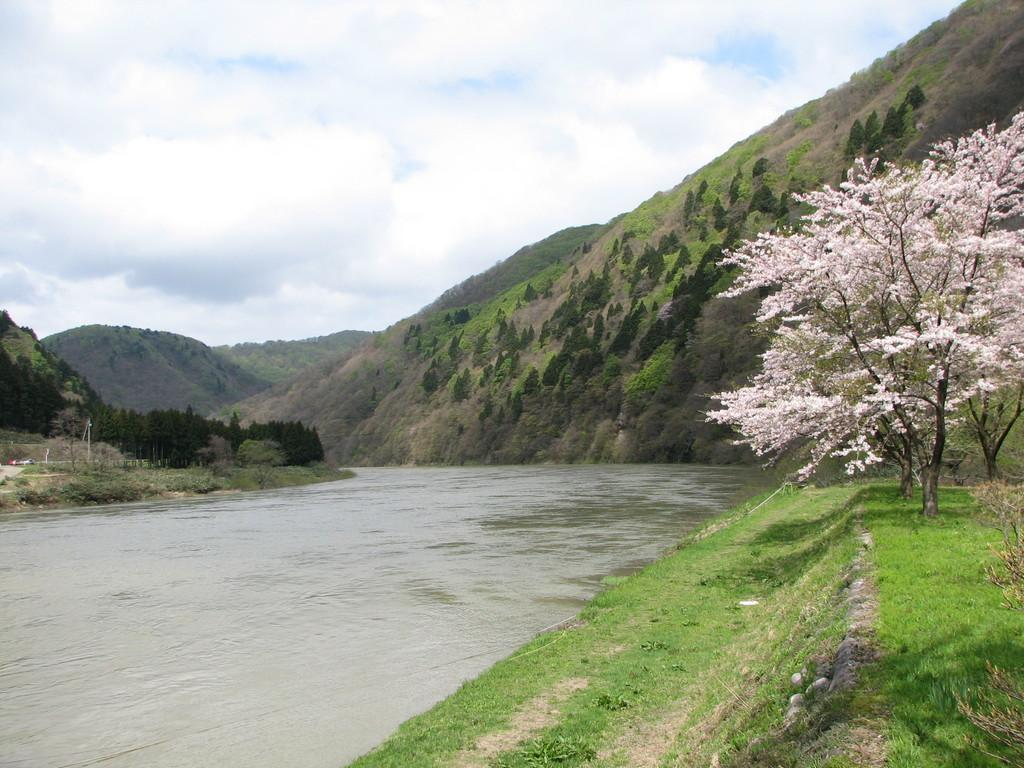What can be seen on the left side of the image? There is water on the left side of the image. What is located on the right side of the image? There are trees on the right side of the image. What type of landscape feature is visible in the background of the image? There are hills visible in the background of the image. What is visible at the top of the image? The sky is visible at the top of the image. What reward is being given to the coach in the image? There is no coach or reward present in the image. What addition can be seen in the image? There is no addition or any indication of a mathematical operation in the image. 